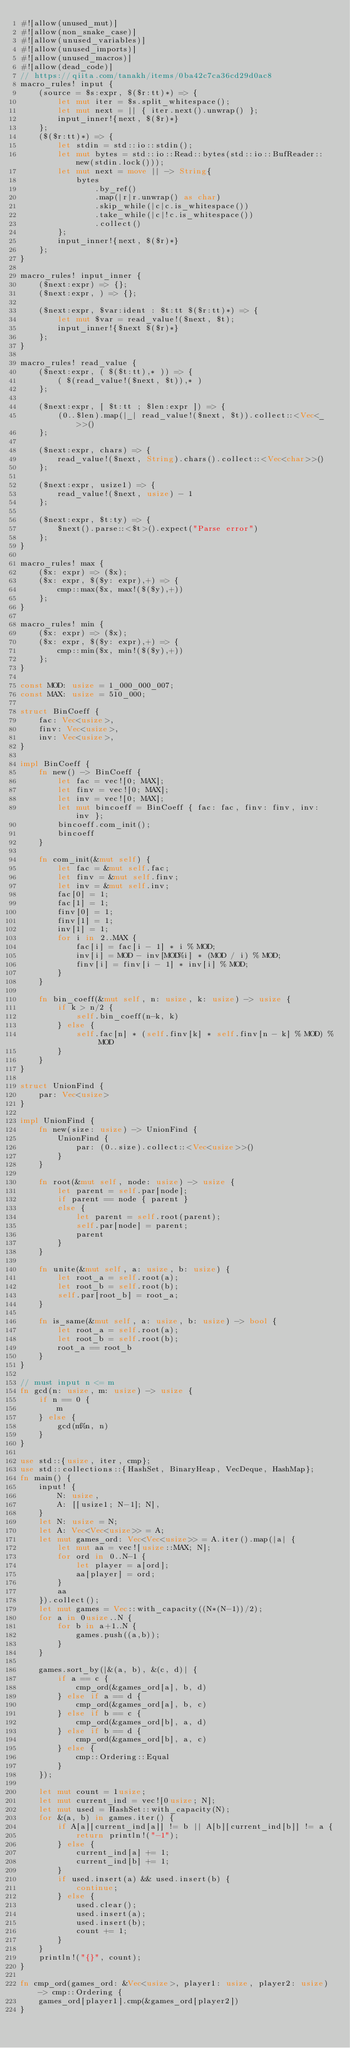Convert code to text. <code><loc_0><loc_0><loc_500><loc_500><_Rust_>#![allow(unused_mut)]
#![allow(non_snake_case)]
#![allow(unused_variables)]
#![allow(unused_imports)]
#![allow(unused_macros)]
#![allow(dead_code)]
// https://qiita.com/tanakh/items/0ba42c7ca36cd29d0ac8
macro_rules! input {
    (source = $s:expr, $($r:tt)*) => {
        let mut iter = $s.split_whitespace();
        let mut next = || { iter.next().unwrap() };
        input_inner!{next, $($r)*}
    };
    ($($r:tt)*) => {
        let stdin = std::io::stdin();
        let mut bytes = std::io::Read::bytes(std::io::BufReader::new(stdin.lock()));
        let mut next = move || -> String{
            bytes
                .by_ref()
                .map(|r|r.unwrap() as char)
                .skip_while(|c|c.is_whitespace())
                .take_while(|c|!c.is_whitespace())
                .collect()
        };
        input_inner!{next, $($r)*}
    };
}

macro_rules! input_inner {
    ($next:expr) => {};
    ($next:expr, ) => {};

    ($next:expr, $var:ident : $t:tt $($r:tt)*) => {
        let mut $var = read_value!($next, $t);
        input_inner!{$next $($r)*}
    };
}

macro_rules! read_value {
    ($next:expr, ( $($t:tt),* )) => {
        ( $(read_value!($next, $t)),* )
    };

    ($next:expr, [ $t:tt ; $len:expr ]) => {
        (0..$len).map(|_| read_value!($next, $t)).collect::<Vec<_>>()
    };

    ($next:expr, chars) => {
        read_value!($next, String).chars().collect::<Vec<char>>()
    };

    ($next:expr, usize1) => {
        read_value!($next, usize) - 1
    };

    ($next:expr, $t:ty) => {
        $next().parse::<$t>().expect("Parse error")
    };
}

macro_rules! max {
    ($x: expr) => ($x);
    ($x: expr, $($y: expr),+) => {
        cmp::max($x, max!($($y),+))
    };
}

macro_rules! min {
    ($x: expr) => ($x);
    ($x: expr, $($y: expr),+) => {
        cmp::min($x, min!($($y),+))
    };
}

const MOD: usize = 1_000_000_007;
const MAX: usize = 510_000;

struct BinCoeff {
    fac: Vec<usize>,
    finv: Vec<usize>,
    inv: Vec<usize>,
}

impl BinCoeff {
    fn new() -> BinCoeff {
        let fac = vec![0; MAX];
        let finv = vec![0; MAX];
        let inv = vec![0; MAX];
        let mut bincoeff = BinCoeff { fac: fac, finv: finv, inv: inv };
        bincoeff.com_init();
        bincoeff
    }

    fn com_init(&mut self) {
        let fac = &mut self.fac;
        let finv = &mut self.finv;
        let inv = &mut self.inv;
        fac[0] = 1;
        fac[1] = 1;
        finv[0] = 1;
        finv[1] = 1;
        inv[1] = 1;
        for i in 2..MAX {
            fac[i] = fac[i - 1] * i % MOD;
            inv[i] = MOD - inv[MOD%i] * (MOD / i) % MOD;
            finv[i] = finv[i - 1] * inv[i] % MOD;
        }
    }

    fn bin_coeff(&mut self, n: usize, k: usize) -> usize {
        if k > n/2 {
            self.bin_coeff(n-k, k)
        } else {
            self.fac[n] * (self.finv[k] * self.finv[n - k] % MOD) % MOD
        }
    }
}

struct UnionFind {
    par: Vec<usize>
}

impl UnionFind {
    fn new(size: usize) -> UnionFind {
        UnionFind {
            par: (0..size).collect::<Vec<usize>>()
        }
    }

    fn root(&mut self, node: usize) -> usize {
        let parent = self.par[node];
        if parent == node { parent }
        else {
            let parent = self.root(parent);
            self.par[node] = parent;
            parent
        }
    }

    fn unite(&mut self, a: usize, b: usize) {
        let root_a = self.root(a);
        let root_b = self.root(b);
        self.par[root_b] = root_a;
    }

    fn is_same(&mut self, a: usize, b: usize) -> bool {
        let root_a = self.root(a);
        let root_b = self.root(b);
        root_a == root_b
    }
}

// must input n <= m
fn gcd(n: usize, m: usize) -> usize {
    if n == 0 {
        m
    } else {
        gcd(m%n, n)
    }
}

use std::{usize, iter, cmp};
use std::collections::{HashSet, BinaryHeap, VecDeque, HashMap};
fn main() {
    input! {
        N: usize,
        A: [[usize1; N-1]; N],
    }
    let N: usize = N;
    let A: Vec<Vec<usize>> = A;
    let mut games_ord: Vec<Vec<usize>> = A.iter().map(|a| {
        let mut aa = vec![usize::MAX; N];
        for ord in 0..N-1 {
            let player = a[ord];
            aa[player] = ord;
        }
        aa
    }).collect();
    let mut games = Vec::with_capacity((N*(N-1))/2);
    for a in 0usize..N {
        for b in a+1..N {
            games.push((a,b));
        }
    }

    games.sort_by(|&(a, b), &(c, d)| {
        if a == c {
            cmp_ord(&games_ord[a], b, d)
        } else if a == d {
            cmp_ord(&games_ord[a], b, c)
        } else if b == c {
            cmp_ord(&games_ord[b], a, d)
        } else if b == d {
            cmp_ord(&games_ord[b], a, c)
        } else {
            cmp::Ordering::Equal
        }
    });

    let mut count = 1usize;
    let mut current_ind = vec![0usize; N];
    let mut used = HashSet::with_capacity(N);
    for &(a, b) in games.iter() {
        if A[a][current_ind[a]] != b || A[b][current_ind[b]] != a {
            return println!("-1");
        } else {
            current_ind[a] += 1;
            current_ind[b] += 1;
        }
        if used.insert(a) && used.insert(b) {
            continue;
        } else {
            used.clear();
            used.insert(a);
            used.insert(b);
            count += 1;
        }
    }
    println!("{}", count);
}

fn cmp_ord(games_ord: &Vec<usize>, player1: usize, player2: usize) -> cmp::Ordering {
    games_ord[player1].cmp(&games_ord[player2])
}

</code> 